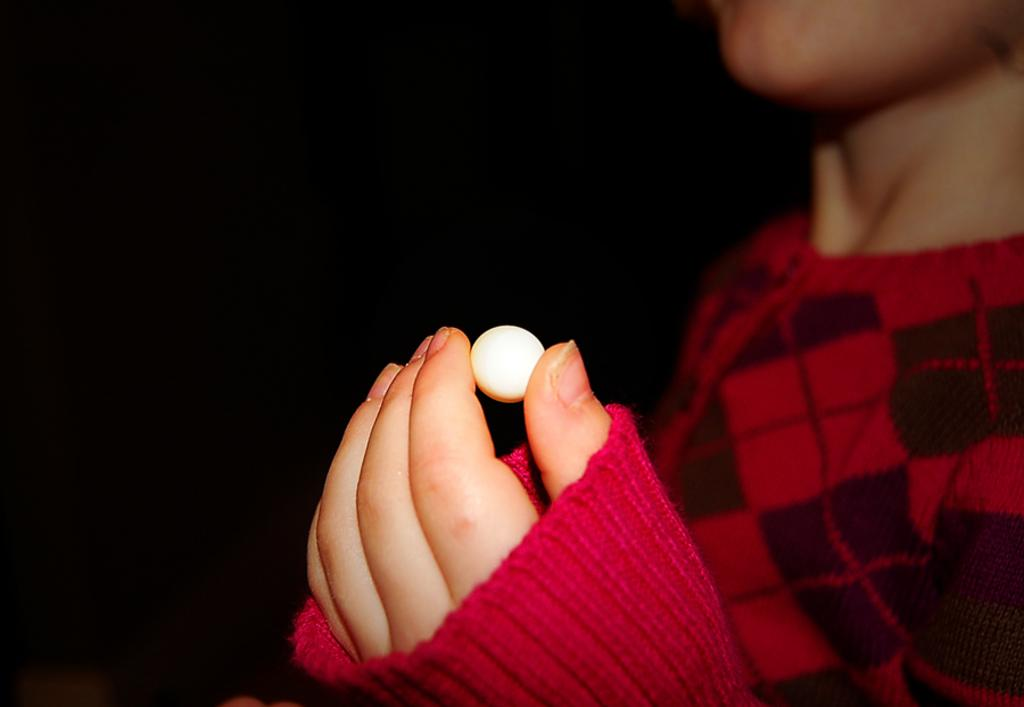What is the main subject of the picture? The main subject of the picture is a small boy. What is the boy wearing? The boy is wearing a red sweater. What is the boy's posture in the image? The boy is standing. What object is the boy holding in his hand? The boy is holding a small white ball in his hand. What is the color of the background in the image? The background in the image is black. What type of rhythm can be heard coming from the border in the image? There is no border present in the image, and therefore no rhythm can be heard. 